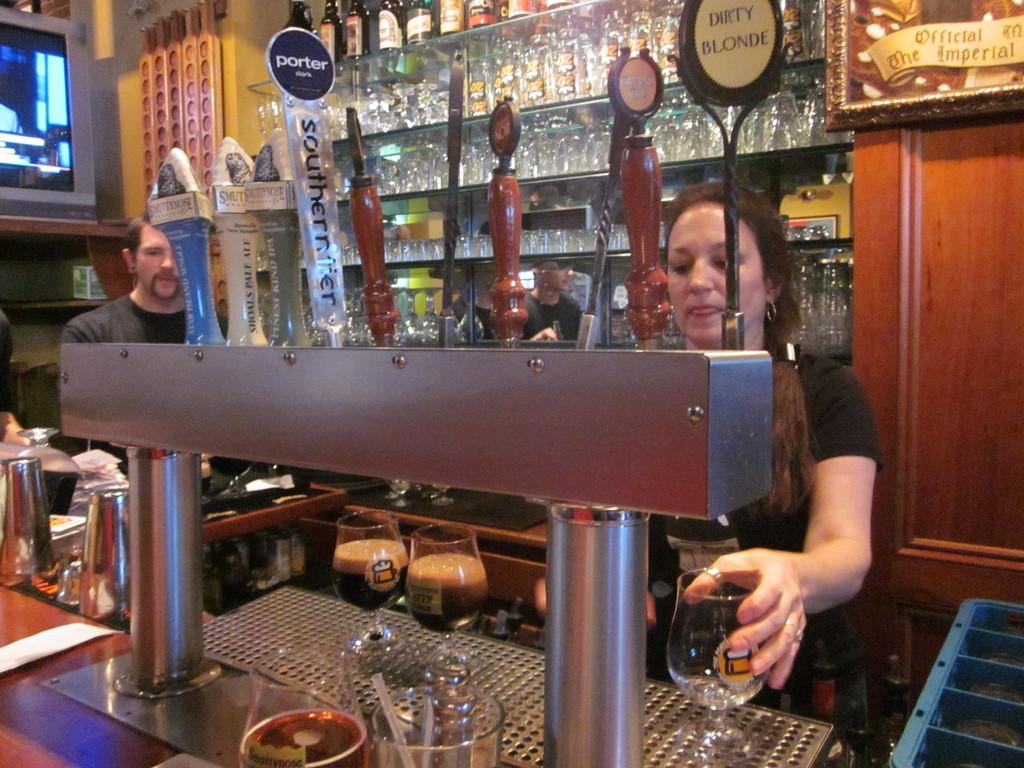<image>
Render a clear and concise summary of the photo. a view of a bar worker pulling beers like Porter dark and Dirty Blonde 